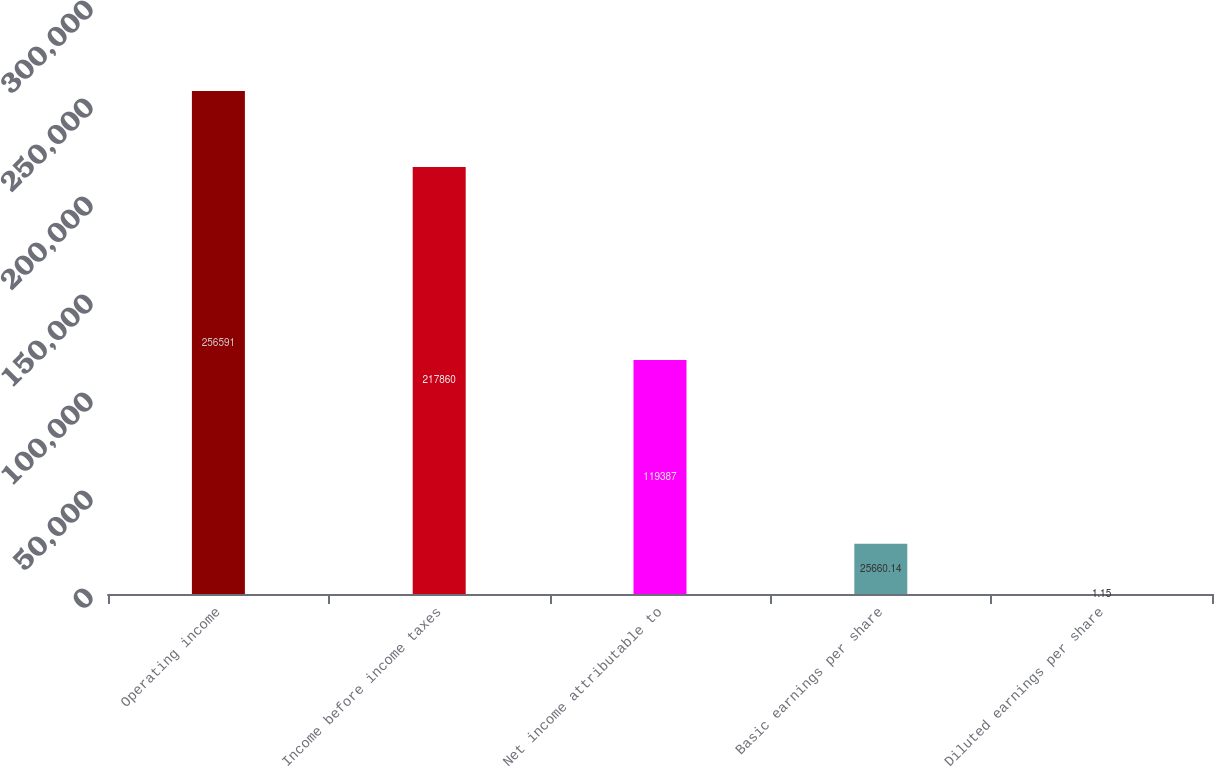<chart> <loc_0><loc_0><loc_500><loc_500><bar_chart><fcel>Operating income<fcel>Income before income taxes<fcel>Net income attributable to<fcel>Basic earnings per share<fcel>Diluted earnings per share<nl><fcel>256591<fcel>217860<fcel>119387<fcel>25660.1<fcel>1.15<nl></chart> 